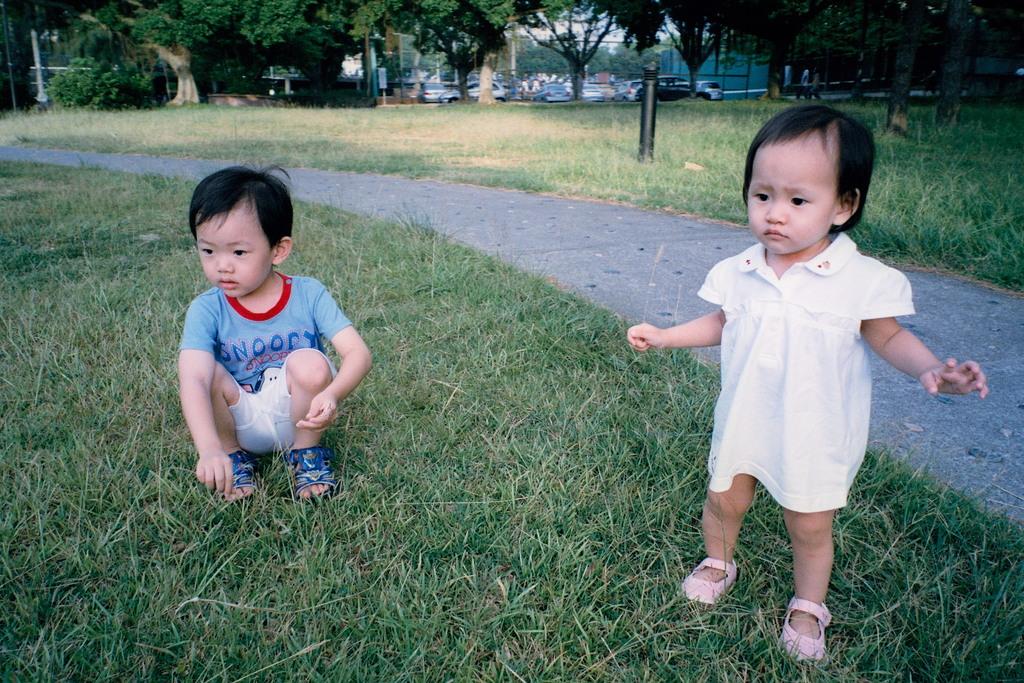What is the cartoon dogs name on the child shirt?
Give a very brief answer. Snoopy. 